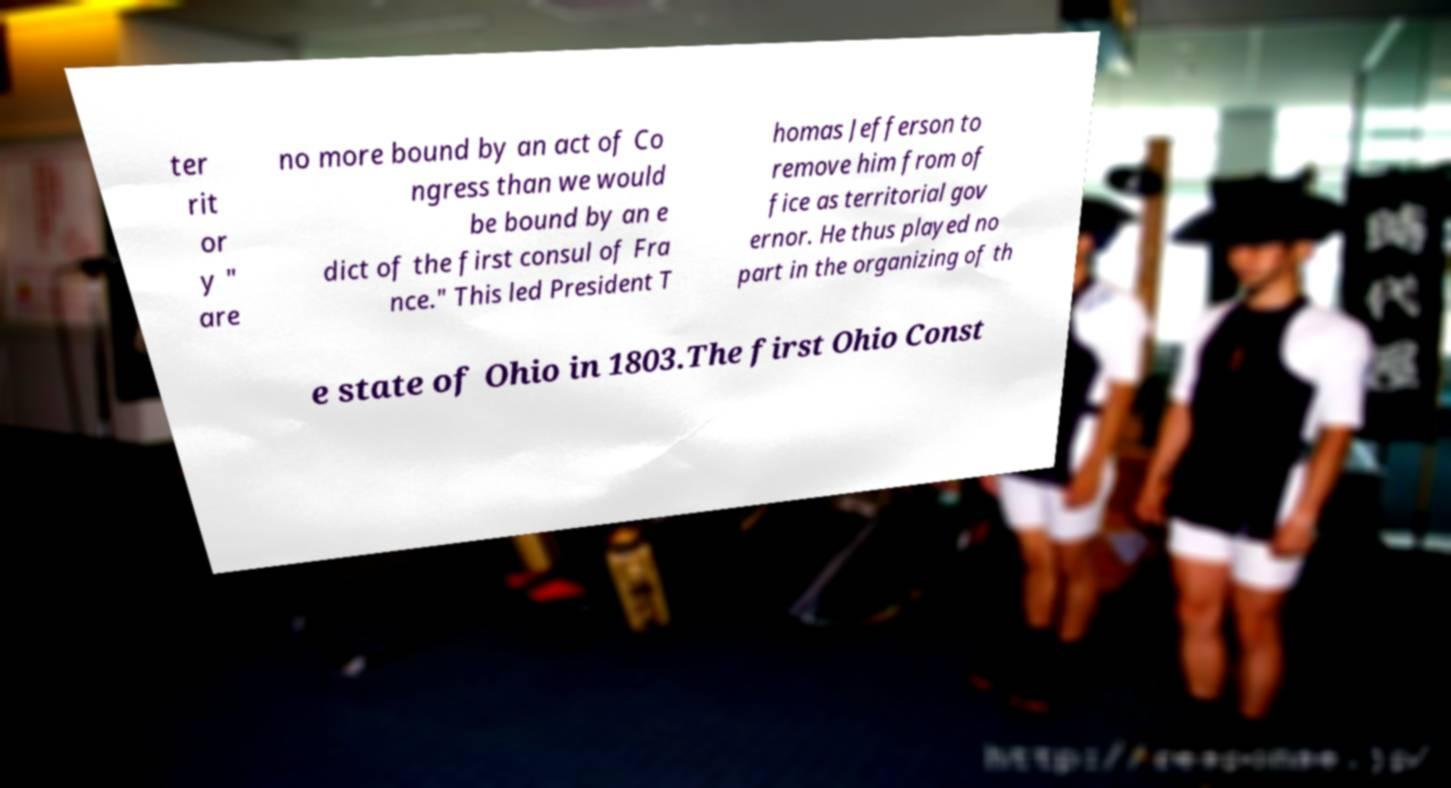Could you assist in decoding the text presented in this image and type it out clearly? ter rit or y " are no more bound by an act of Co ngress than we would be bound by an e dict of the first consul of Fra nce." This led President T homas Jefferson to remove him from of fice as territorial gov ernor. He thus played no part in the organizing of th e state of Ohio in 1803.The first Ohio Const 